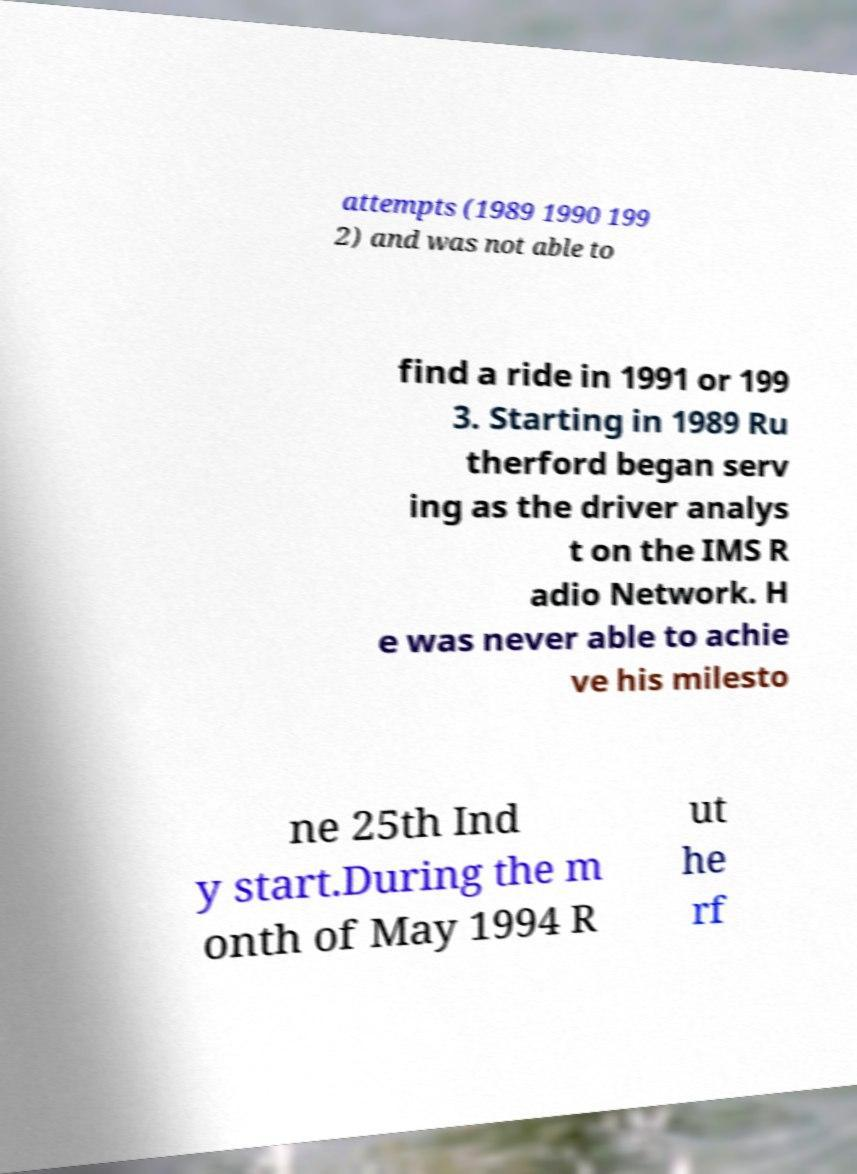Please read and relay the text visible in this image. What does it say? attempts (1989 1990 199 2) and was not able to find a ride in 1991 or 199 3. Starting in 1989 Ru therford began serv ing as the driver analys t on the IMS R adio Network. H e was never able to achie ve his milesto ne 25th Ind y start.During the m onth of May 1994 R ut he rf 